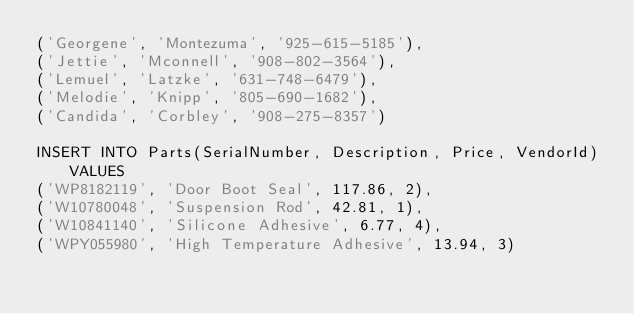<code> <loc_0><loc_0><loc_500><loc_500><_SQL_>('Georgene', 'Montezuma', '925-615-5185'),
('Jettie', 'Mconnell', '908-802-3564'),
('Lemuel', 'Latzke', '631-748-6479'),
('Melodie', 'Knipp', '805-690-1682'),
('Candida', 'Corbley', '908-275-8357')

INSERT INTO Parts(SerialNumber, Description, Price, VendorId) VALUES 
('WP8182119', 'Door Boot Seal', 117.86, 2),
('W10780048', 'Suspension Rod', 42.81, 1),
('W10841140', 'Silicone Adhesive', 6.77, 4),
('WPY055980', 'High Temperature Adhesive', 13.94, 3)</code> 